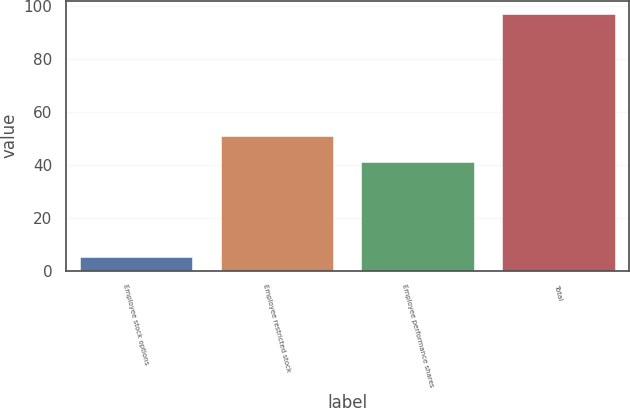Convert chart to OTSL. <chart><loc_0><loc_0><loc_500><loc_500><bar_chart><fcel>Employee stock options<fcel>Employee restricted stock<fcel>Employee performance shares<fcel>Total<nl><fcel>5<fcel>51<fcel>41<fcel>97<nl></chart> 